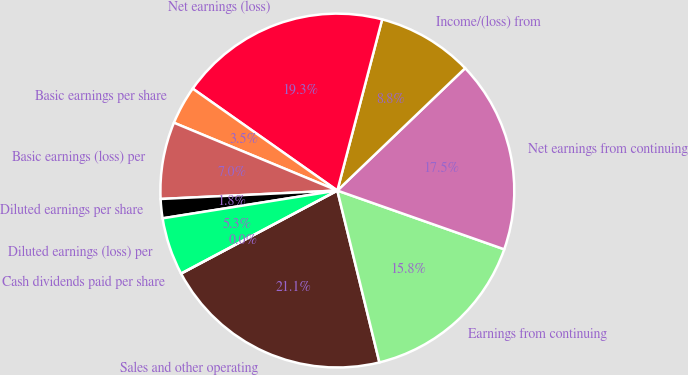<chart> <loc_0><loc_0><loc_500><loc_500><pie_chart><fcel>Sales and other operating<fcel>Earnings from continuing<fcel>Net earnings from continuing<fcel>Income/(loss) from<fcel>Net earnings (loss)<fcel>Basic earnings per share<fcel>Basic earnings (loss) per<fcel>Diluted earnings per share<fcel>Diluted earnings (loss) per<fcel>Cash dividends paid per share<nl><fcel>21.05%<fcel>15.79%<fcel>17.54%<fcel>8.77%<fcel>19.3%<fcel>3.51%<fcel>7.02%<fcel>1.75%<fcel>5.26%<fcel>0.0%<nl></chart> 